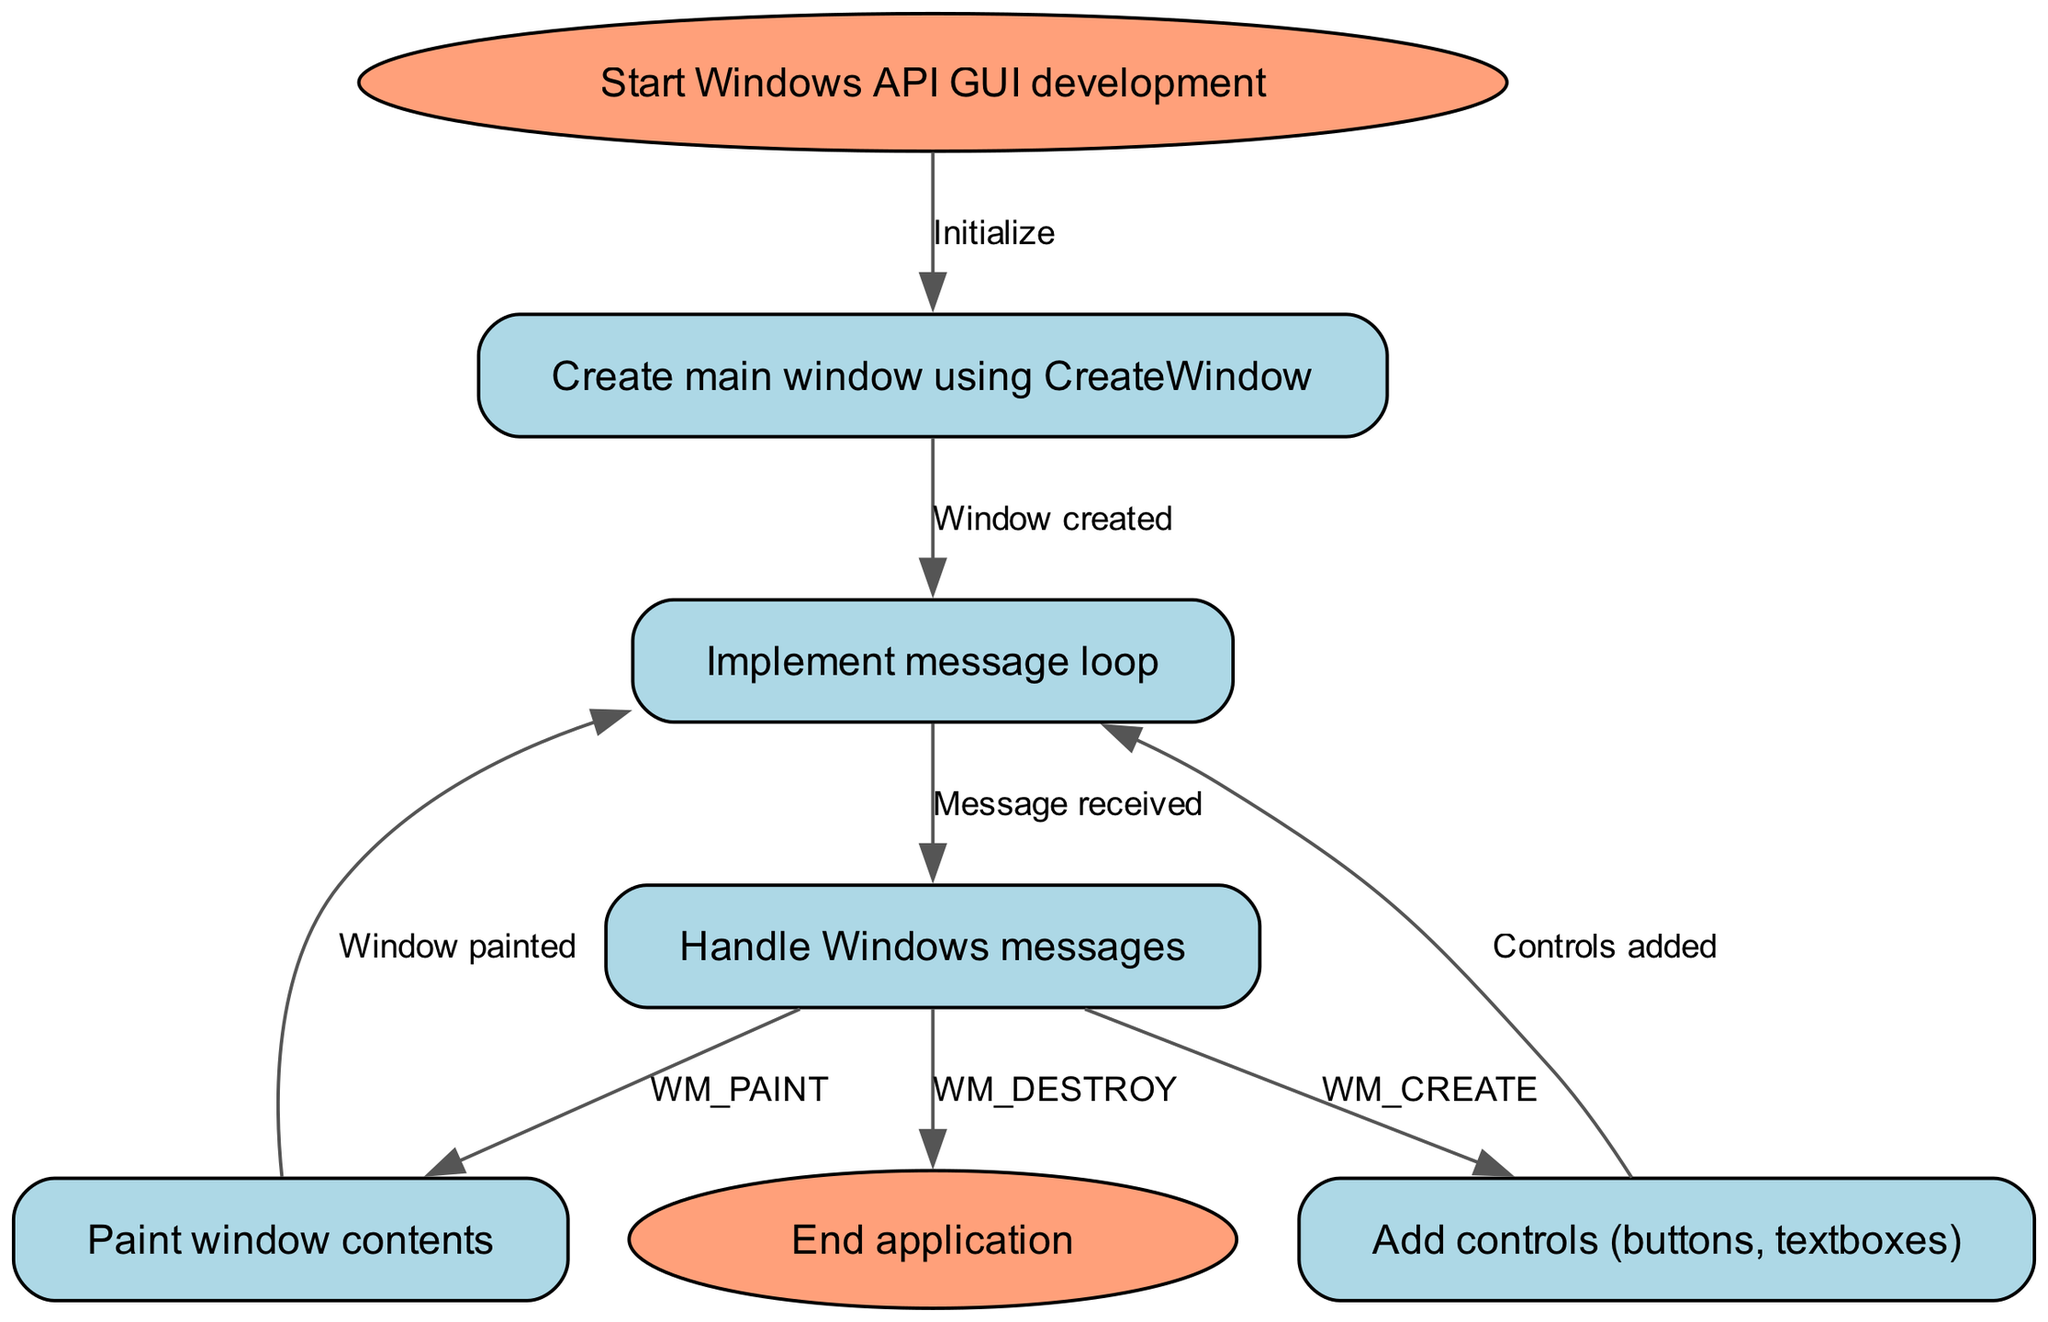What is the first step in the flowchart? The first step is labeled as "Start Windows API GUI development." This is the entry point into the flowchart and indicates the beginning of the process.
Answer: Start Windows API GUI development How many nodes are present in the diagram? By counting the nodes listed in the flowchart, we can confirm there are a total of seven nodes. This includes start, create window, message loop, handle messages, add controls, paint window, and end.
Answer: Seven What action follows after creating the main window? After the main window is created using CreateWindow, the next action in the flow is to implement the message loop, as indicated by the edge leading from "create_window" to "message_loop."
Answer: Implement message loop Which message is handled to add controls? The WM_CREATE message is specifically handled to transition to the "Add controls" step, as indicated in the flowchart. This is the trigger that leads to adding various GUI controls.
Answer: WM_CREATE What is the last step in the flowchart? The final step in the flowchart is to "End application," which represents the conclusion of the program's operation after handling messages and painting the window.
Answer: End application What triggers the transition from painting the window back to the message loop? The transition from "paint_window" back to "message_loop" occurs after the window contents have been painted, as shown in the flowchart. This indicates that the application is still processing messages following the painting process.
Answer: Window painted How does the flow proceed after handling a WM_DESTROY message? After handling the WM_DESTROY message, the flow leads directly to the end of the application, indicating that this message signifies the termination of the GUI.
Answer: End application What type of message is received in the message loop? The message loop is designed to receive various Windows messages, which include WM_CREATE and WM_PAINT among others, as shown in the diagram.
Answer: Windows messages 